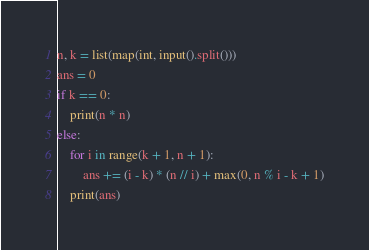Convert code to text. <code><loc_0><loc_0><loc_500><loc_500><_Python_>n, k = list(map(int, input().split()))
ans = 0
if k == 0:
    print(n * n)
else:
    for i in range(k + 1, n + 1):
        ans += (i - k) * (n // i) + max(0, n % i - k + 1)
    print(ans)</code> 